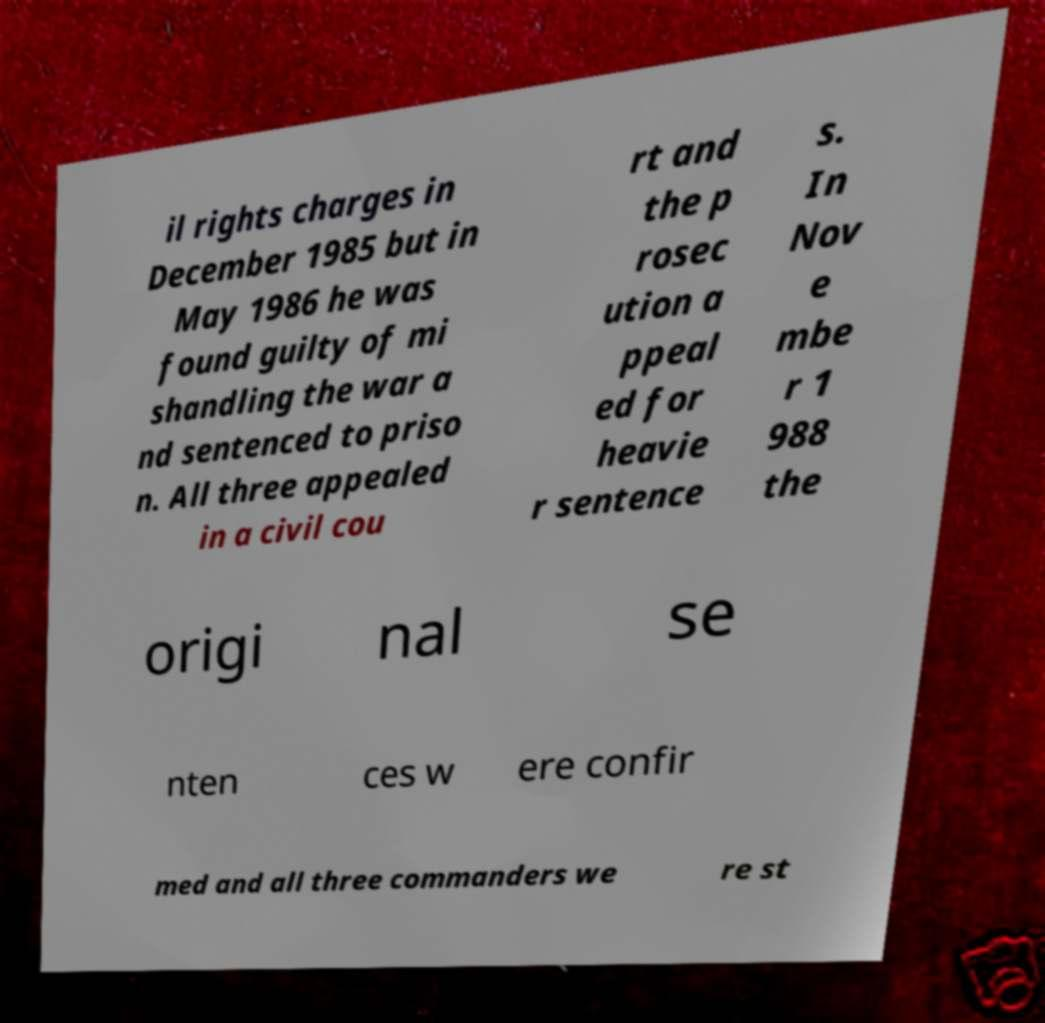Please identify and transcribe the text found in this image. il rights charges in December 1985 but in May 1986 he was found guilty of mi shandling the war a nd sentenced to priso n. All three appealed in a civil cou rt and the p rosec ution a ppeal ed for heavie r sentence s. In Nov e mbe r 1 988 the origi nal se nten ces w ere confir med and all three commanders we re st 